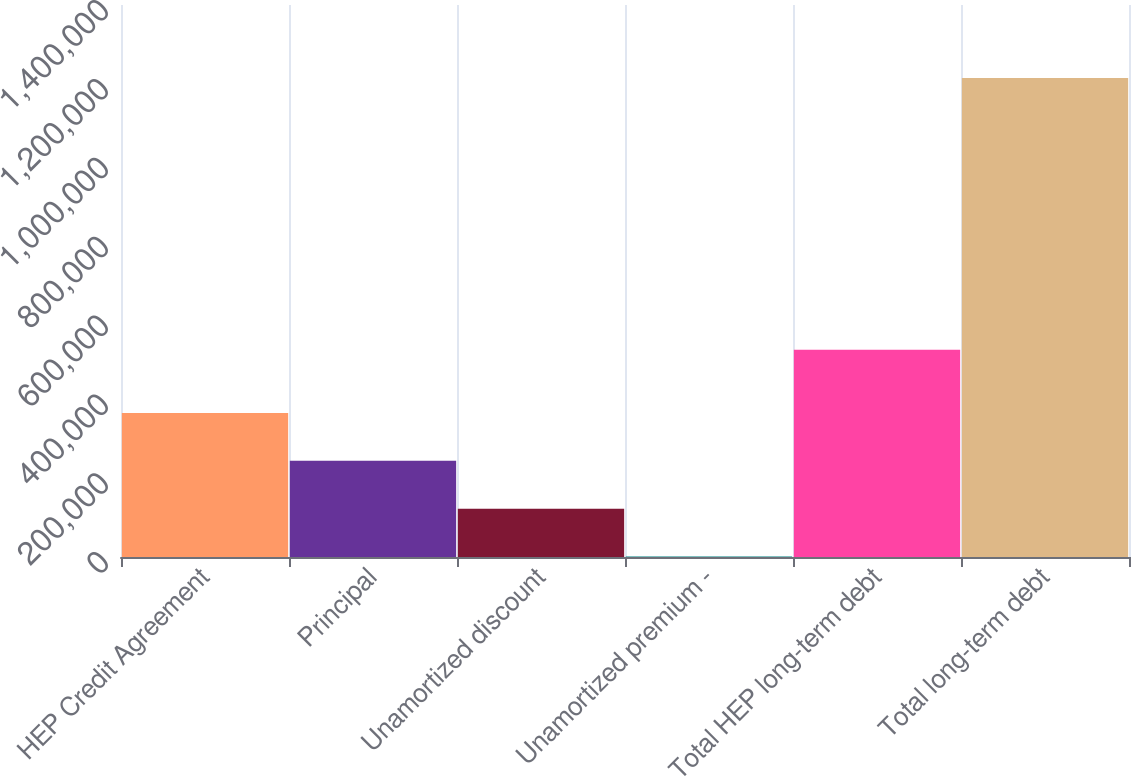Convert chart. <chart><loc_0><loc_0><loc_500><loc_500><bar_chart><fcel>HEP Credit Agreement<fcel>Principal<fcel>Unamortized discount<fcel>Unamortized premium -<fcel>Total HEP long-term debt<fcel>Total long-term debt<nl><fcel>365191<fcel>243827<fcel>122462<fcel>1098<fcel>525860<fcel>1.21474e+06<nl></chart> 